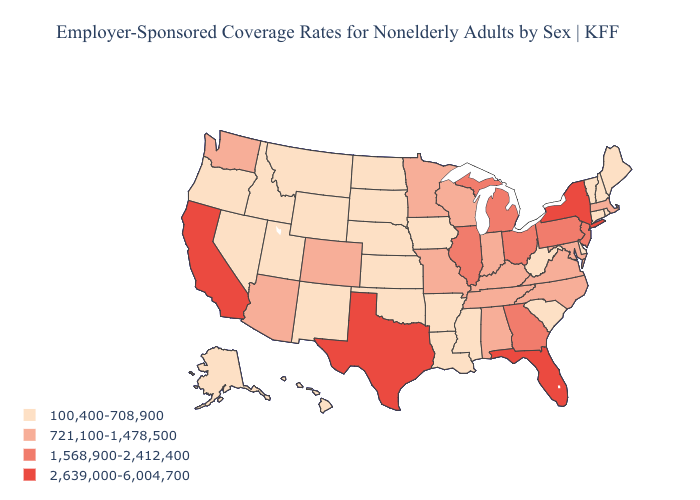What is the highest value in states that border Tennessee?
Concise answer only. 1,568,900-2,412,400. Name the states that have a value in the range 2,639,000-6,004,700?
Short answer required. California, Florida, New York, Texas. Does Virginia have a lower value than Georgia?
Short answer required. Yes. What is the lowest value in the West?
Short answer required. 100,400-708,900. What is the value of Connecticut?
Short answer required. 100,400-708,900. Does the first symbol in the legend represent the smallest category?
Concise answer only. Yes. Among the states that border Tennessee , which have the highest value?
Give a very brief answer. Georgia. Which states have the highest value in the USA?
Concise answer only. California, Florida, New York, Texas. Is the legend a continuous bar?
Concise answer only. No. Name the states that have a value in the range 100,400-708,900?
Write a very short answer. Alaska, Arkansas, Connecticut, Delaware, Hawaii, Idaho, Iowa, Kansas, Louisiana, Maine, Mississippi, Montana, Nebraska, Nevada, New Hampshire, New Mexico, North Dakota, Oklahoma, Oregon, Rhode Island, South Carolina, South Dakota, Utah, Vermont, West Virginia, Wyoming. Does the map have missing data?
Answer briefly. No. What is the value of West Virginia?
Answer briefly. 100,400-708,900. Which states have the highest value in the USA?
Write a very short answer. California, Florida, New York, Texas. What is the highest value in states that border Iowa?
Be succinct. 1,568,900-2,412,400. 